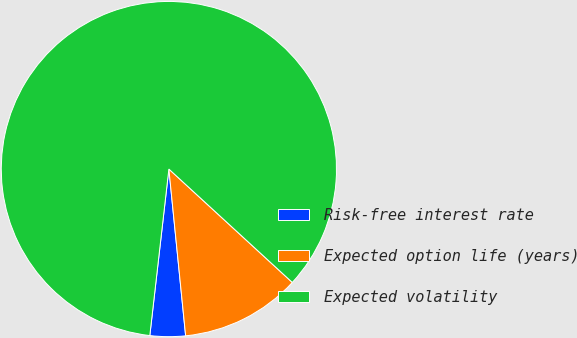Convert chart. <chart><loc_0><loc_0><loc_500><loc_500><pie_chart><fcel>Risk-free interest rate<fcel>Expected option life (years)<fcel>Expected volatility<nl><fcel>3.41%<fcel>11.58%<fcel>85.02%<nl></chart> 